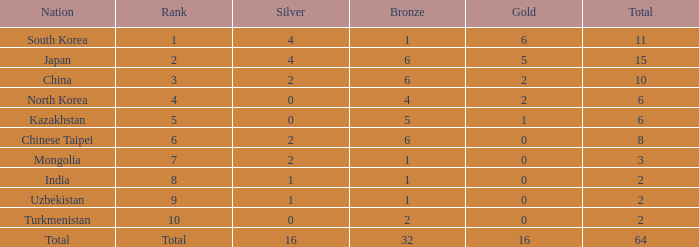How many Golds did Rank 10 get, with a Bronze larger than 2? 0.0. 